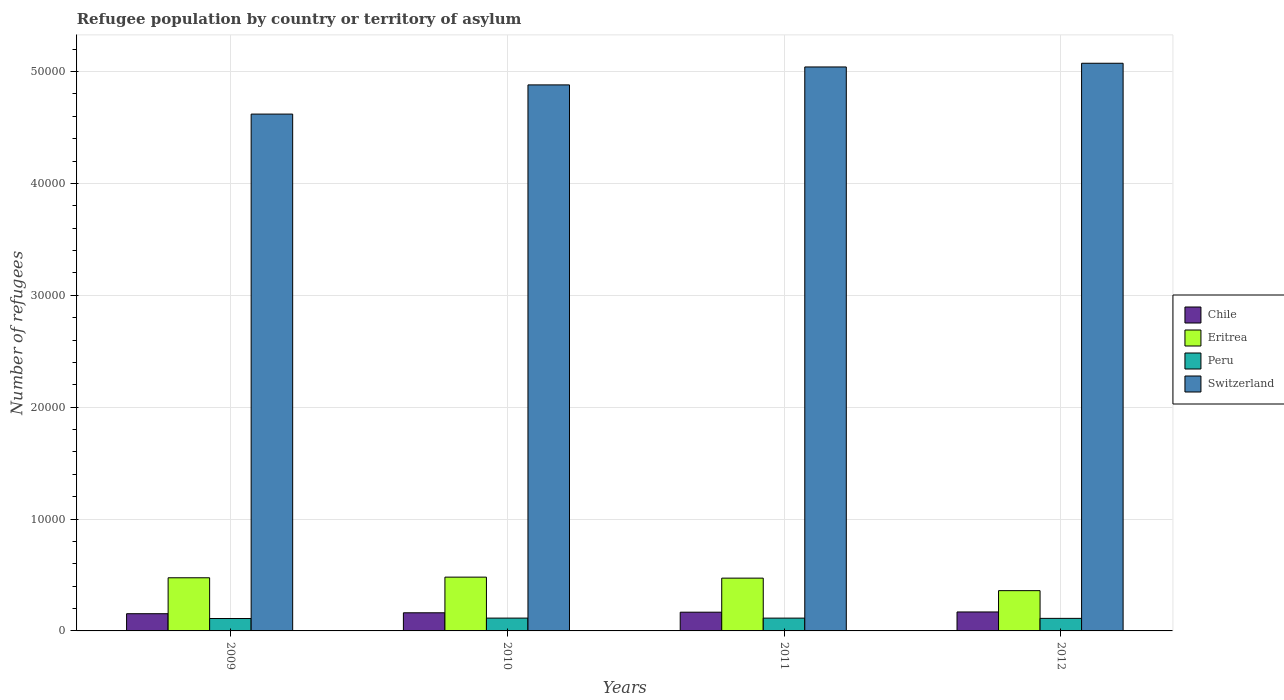How many different coloured bars are there?
Keep it short and to the point. 4. Are the number of bars per tick equal to the number of legend labels?
Make the answer very short. Yes. What is the label of the 3rd group of bars from the left?
Your answer should be compact. 2011. What is the number of refugees in Eritrea in 2012?
Keep it short and to the point. 3600. Across all years, what is the maximum number of refugees in Peru?
Make the answer very short. 1146. Across all years, what is the minimum number of refugees in Chile?
Your answer should be very brief. 1539. In which year was the number of refugees in Peru maximum?
Keep it short and to the point. 2010. What is the total number of refugees in Switzerland in the graph?
Make the answer very short. 1.96e+05. What is the difference between the number of refugees in Chile in 2009 and that in 2012?
Make the answer very short. -156. What is the difference between the number of refugees in Eritrea in 2011 and the number of refugees in Peru in 2009?
Keep it short and to the point. 3611. What is the average number of refugees in Switzerland per year?
Your answer should be compact. 4.90e+04. In the year 2012, what is the difference between the number of refugees in Switzerland and number of refugees in Peru?
Your answer should be compact. 4.96e+04. In how many years, is the number of refugees in Peru greater than 40000?
Your response must be concise. 0. What is the ratio of the number of refugees in Peru in 2009 to that in 2012?
Keep it short and to the point. 0.99. Is the number of refugees in Chile in 2009 less than that in 2011?
Give a very brief answer. Yes. What is the difference between the highest and the lowest number of refugees in Switzerland?
Ensure brevity in your answer.  4544. Is the sum of the number of refugees in Chile in 2010 and 2012 greater than the maximum number of refugees in Peru across all years?
Your answer should be compact. Yes. How many bars are there?
Keep it short and to the point. 16. What is the difference between two consecutive major ticks on the Y-axis?
Give a very brief answer. 10000. Does the graph contain any zero values?
Offer a terse response. No. Where does the legend appear in the graph?
Provide a succinct answer. Center right. How many legend labels are there?
Offer a very short reply. 4. How are the legend labels stacked?
Make the answer very short. Vertical. What is the title of the graph?
Your answer should be compact. Refugee population by country or territory of asylum. What is the label or title of the X-axis?
Your response must be concise. Years. What is the label or title of the Y-axis?
Offer a very short reply. Number of refugees. What is the Number of refugees in Chile in 2009?
Provide a short and direct response. 1539. What is the Number of refugees of Eritrea in 2009?
Your answer should be compact. 4751. What is the Number of refugees of Peru in 2009?
Keep it short and to the point. 1108. What is the Number of refugees in Switzerland in 2009?
Offer a very short reply. 4.62e+04. What is the Number of refugees of Chile in 2010?
Provide a succinct answer. 1621. What is the Number of refugees in Eritrea in 2010?
Your response must be concise. 4809. What is the Number of refugees of Peru in 2010?
Your response must be concise. 1146. What is the Number of refugees of Switzerland in 2010?
Offer a terse response. 4.88e+04. What is the Number of refugees of Chile in 2011?
Give a very brief answer. 1674. What is the Number of refugees of Eritrea in 2011?
Offer a very short reply. 4719. What is the Number of refugees in Peru in 2011?
Make the answer very short. 1144. What is the Number of refugees of Switzerland in 2011?
Your answer should be very brief. 5.04e+04. What is the Number of refugees in Chile in 2012?
Your answer should be compact. 1695. What is the Number of refugees in Eritrea in 2012?
Your answer should be compact. 3600. What is the Number of refugees in Peru in 2012?
Provide a short and direct response. 1122. What is the Number of refugees in Switzerland in 2012?
Make the answer very short. 5.07e+04. Across all years, what is the maximum Number of refugees of Chile?
Make the answer very short. 1695. Across all years, what is the maximum Number of refugees in Eritrea?
Ensure brevity in your answer.  4809. Across all years, what is the maximum Number of refugees of Peru?
Offer a very short reply. 1146. Across all years, what is the maximum Number of refugees in Switzerland?
Your answer should be compact. 5.07e+04. Across all years, what is the minimum Number of refugees of Chile?
Provide a succinct answer. 1539. Across all years, what is the minimum Number of refugees in Eritrea?
Your response must be concise. 3600. Across all years, what is the minimum Number of refugees of Peru?
Provide a short and direct response. 1108. Across all years, what is the minimum Number of refugees in Switzerland?
Offer a terse response. 4.62e+04. What is the total Number of refugees in Chile in the graph?
Ensure brevity in your answer.  6529. What is the total Number of refugees of Eritrea in the graph?
Make the answer very short. 1.79e+04. What is the total Number of refugees of Peru in the graph?
Offer a very short reply. 4520. What is the total Number of refugees of Switzerland in the graph?
Give a very brief answer. 1.96e+05. What is the difference between the Number of refugees in Chile in 2009 and that in 2010?
Offer a terse response. -82. What is the difference between the Number of refugees of Eritrea in 2009 and that in 2010?
Provide a succinct answer. -58. What is the difference between the Number of refugees of Peru in 2009 and that in 2010?
Ensure brevity in your answer.  -38. What is the difference between the Number of refugees of Switzerland in 2009 and that in 2010?
Provide a succinct answer. -2610. What is the difference between the Number of refugees in Chile in 2009 and that in 2011?
Your response must be concise. -135. What is the difference between the Number of refugees of Eritrea in 2009 and that in 2011?
Your response must be concise. 32. What is the difference between the Number of refugees in Peru in 2009 and that in 2011?
Offer a terse response. -36. What is the difference between the Number of refugees in Switzerland in 2009 and that in 2011?
Give a very brief answer. -4213. What is the difference between the Number of refugees in Chile in 2009 and that in 2012?
Offer a terse response. -156. What is the difference between the Number of refugees of Eritrea in 2009 and that in 2012?
Your answer should be compact. 1151. What is the difference between the Number of refugees in Peru in 2009 and that in 2012?
Your response must be concise. -14. What is the difference between the Number of refugees in Switzerland in 2009 and that in 2012?
Keep it short and to the point. -4544. What is the difference between the Number of refugees of Chile in 2010 and that in 2011?
Give a very brief answer. -53. What is the difference between the Number of refugees in Peru in 2010 and that in 2011?
Provide a short and direct response. 2. What is the difference between the Number of refugees in Switzerland in 2010 and that in 2011?
Provide a short and direct response. -1603. What is the difference between the Number of refugees in Chile in 2010 and that in 2012?
Keep it short and to the point. -74. What is the difference between the Number of refugees of Eritrea in 2010 and that in 2012?
Give a very brief answer. 1209. What is the difference between the Number of refugees of Peru in 2010 and that in 2012?
Your response must be concise. 24. What is the difference between the Number of refugees of Switzerland in 2010 and that in 2012?
Your response must be concise. -1934. What is the difference between the Number of refugees of Chile in 2011 and that in 2012?
Your answer should be very brief. -21. What is the difference between the Number of refugees of Eritrea in 2011 and that in 2012?
Give a very brief answer. 1119. What is the difference between the Number of refugees in Switzerland in 2011 and that in 2012?
Your answer should be compact. -331. What is the difference between the Number of refugees of Chile in 2009 and the Number of refugees of Eritrea in 2010?
Offer a terse response. -3270. What is the difference between the Number of refugees of Chile in 2009 and the Number of refugees of Peru in 2010?
Provide a short and direct response. 393. What is the difference between the Number of refugees in Chile in 2009 and the Number of refugees in Switzerland in 2010?
Give a very brief answer. -4.73e+04. What is the difference between the Number of refugees of Eritrea in 2009 and the Number of refugees of Peru in 2010?
Offer a terse response. 3605. What is the difference between the Number of refugees in Eritrea in 2009 and the Number of refugees in Switzerland in 2010?
Make the answer very short. -4.41e+04. What is the difference between the Number of refugees of Peru in 2009 and the Number of refugees of Switzerland in 2010?
Keep it short and to the point. -4.77e+04. What is the difference between the Number of refugees in Chile in 2009 and the Number of refugees in Eritrea in 2011?
Make the answer very short. -3180. What is the difference between the Number of refugees in Chile in 2009 and the Number of refugees in Peru in 2011?
Offer a very short reply. 395. What is the difference between the Number of refugees in Chile in 2009 and the Number of refugees in Switzerland in 2011?
Give a very brief answer. -4.89e+04. What is the difference between the Number of refugees in Eritrea in 2009 and the Number of refugees in Peru in 2011?
Provide a short and direct response. 3607. What is the difference between the Number of refugees in Eritrea in 2009 and the Number of refugees in Switzerland in 2011?
Offer a terse response. -4.57e+04. What is the difference between the Number of refugees of Peru in 2009 and the Number of refugees of Switzerland in 2011?
Offer a terse response. -4.93e+04. What is the difference between the Number of refugees in Chile in 2009 and the Number of refugees in Eritrea in 2012?
Your response must be concise. -2061. What is the difference between the Number of refugees in Chile in 2009 and the Number of refugees in Peru in 2012?
Provide a short and direct response. 417. What is the difference between the Number of refugees of Chile in 2009 and the Number of refugees of Switzerland in 2012?
Offer a terse response. -4.92e+04. What is the difference between the Number of refugees of Eritrea in 2009 and the Number of refugees of Peru in 2012?
Your answer should be very brief. 3629. What is the difference between the Number of refugees of Eritrea in 2009 and the Number of refugees of Switzerland in 2012?
Make the answer very short. -4.60e+04. What is the difference between the Number of refugees in Peru in 2009 and the Number of refugees in Switzerland in 2012?
Offer a terse response. -4.96e+04. What is the difference between the Number of refugees of Chile in 2010 and the Number of refugees of Eritrea in 2011?
Offer a very short reply. -3098. What is the difference between the Number of refugees of Chile in 2010 and the Number of refugees of Peru in 2011?
Offer a very short reply. 477. What is the difference between the Number of refugees of Chile in 2010 and the Number of refugees of Switzerland in 2011?
Keep it short and to the point. -4.88e+04. What is the difference between the Number of refugees of Eritrea in 2010 and the Number of refugees of Peru in 2011?
Offer a very short reply. 3665. What is the difference between the Number of refugees of Eritrea in 2010 and the Number of refugees of Switzerland in 2011?
Provide a short and direct response. -4.56e+04. What is the difference between the Number of refugees in Peru in 2010 and the Number of refugees in Switzerland in 2011?
Offer a very short reply. -4.93e+04. What is the difference between the Number of refugees of Chile in 2010 and the Number of refugees of Eritrea in 2012?
Ensure brevity in your answer.  -1979. What is the difference between the Number of refugees in Chile in 2010 and the Number of refugees in Peru in 2012?
Make the answer very short. 499. What is the difference between the Number of refugees of Chile in 2010 and the Number of refugees of Switzerland in 2012?
Ensure brevity in your answer.  -4.91e+04. What is the difference between the Number of refugees of Eritrea in 2010 and the Number of refugees of Peru in 2012?
Your answer should be very brief. 3687. What is the difference between the Number of refugees in Eritrea in 2010 and the Number of refugees in Switzerland in 2012?
Give a very brief answer. -4.59e+04. What is the difference between the Number of refugees of Peru in 2010 and the Number of refugees of Switzerland in 2012?
Your answer should be very brief. -4.96e+04. What is the difference between the Number of refugees in Chile in 2011 and the Number of refugees in Eritrea in 2012?
Your answer should be very brief. -1926. What is the difference between the Number of refugees in Chile in 2011 and the Number of refugees in Peru in 2012?
Give a very brief answer. 552. What is the difference between the Number of refugees of Chile in 2011 and the Number of refugees of Switzerland in 2012?
Your answer should be compact. -4.91e+04. What is the difference between the Number of refugees of Eritrea in 2011 and the Number of refugees of Peru in 2012?
Your answer should be compact. 3597. What is the difference between the Number of refugees of Eritrea in 2011 and the Number of refugees of Switzerland in 2012?
Give a very brief answer. -4.60e+04. What is the difference between the Number of refugees in Peru in 2011 and the Number of refugees in Switzerland in 2012?
Your answer should be compact. -4.96e+04. What is the average Number of refugees in Chile per year?
Provide a short and direct response. 1632.25. What is the average Number of refugees in Eritrea per year?
Your response must be concise. 4469.75. What is the average Number of refugees of Peru per year?
Your answer should be compact. 1130. What is the average Number of refugees in Switzerland per year?
Your answer should be very brief. 4.90e+04. In the year 2009, what is the difference between the Number of refugees of Chile and Number of refugees of Eritrea?
Your answer should be very brief. -3212. In the year 2009, what is the difference between the Number of refugees in Chile and Number of refugees in Peru?
Provide a short and direct response. 431. In the year 2009, what is the difference between the Number of refugees in Chile and Number of refugees in Switzerland?
Make the answer very short. -4.47e+04. In the year 2009, what is the difference between the Number of refugees in Eritrea and Number of refugees in Peru?
Make the answer very short. 3643. In the year 2009, what is the difference between the Number of refugees of Eritrea and Number of refugees of Switzerland?
Your response must be concise. -4.15e+04. In the year 2009, what is the difference between the Number of refugees of Peru and Number of refugees of Switzerland?
Your answer should be compact. -4.51e+04. In the year 2010, what is the difference between the Number of refugees in Chile and Number of refugees in Eritrea?
Keep it short and to the point. -3188. In the year 2010, what is the difference between the Number of refugees of Chile and Number of refugees of Peru?
Offer a terse response. 475. In the year 2010, what is the difference between the Number of refugees of Chile and Number of refugees of Switzerland?
Offer a terse response. -4.72e+04. In the year 2010, what is the difference between the Number of refugees in Eritrea and Number of refugees in Peru?
Provide a short and direct response. 3663. In the year 2010, what is the difference between the Number of refugees of Eritrea and Number of refugees of Switzerland?
Provide a short and direct response. -4.40e+04. In the year 2010, what is the difference between the Number of refugees of Peru and Number of refugees of Switzerland?
Your answer should be compact. -4.77e+04. In the year 2011, what is the difference between the Number of refugees of Chile and Number of refugees of Eritrea?
Offer a terse response. -3045. In the year 2011, what is the difference between the Number of refugees of Chile and Number of refugees of Peru?
Ensure brevity in your answer.  530. In the year 2011, what is the difference between the Number of refugees in Chile and Number of refugees in Switzerland?
Provide a short and direct response. -4.87e+04. In the year 2011, what is the difference between the Number of refugees in Eritrea and Number of refugees in Peru?
Offer a terse response. 3575. In the year 2011, what is the difference between the Number of refugees in Eritrea and Number of refugees in Switzerland?
Your answer should be compact. -4.57e+04. In the year 2011, what is the difference between the Number of refugees of Peru and Number of refugees of Switzerland?
Your response must be concise. -4.93e+04. In the year 2012, what is the difference between the Number of refugees in Chile and Number of refugees in Eritrea?
Offer a very short reply. -1905. In the year 2012, what is the difference between the Number of refugees of Chile and Number of refugees of Peru?
Offer a terse response. 573. In the year 2012, what is the difference between the Number of refugees in Chile and Number of refugees in Switzerland?
Your response must be concise. -4.91e+04. In the year 2012, what is the difference between the Number of refugees of Eritrea and Number of refugees of Peru?
Ensure brevity in your answer.  2478. In the year 2012, what is the difference between the Number of refugees in Eritrea and Number of refugees in Switzerland?
Ensure brevity in your answer.  -4.71e+04. In the year 2012, what is the difference between the Number of refugees of Peru and Number of refugees of Switzerland?
Keep it short and to the point. -4.96e+04. What is the ratio of the Number of refugees in Chile in 2009 to that in 2010?
Provide a succinct answer. 0.95. What is the ratio of the Number of refugees in Eritrea in 2009 to that in 2010?
Make the answer very short. 0.99. What is the ratio of the Number of refugees in Peru in 2009 to that in 2010?
Your answer should be compact. 0.97. What is the ratio of the Number of refugees of Switzerland in 2009 to that in 2010?
Keep it short and to the point. 0.95. What is the ratio of the Number of refugees of Chile in 2009 to that in 2011?
Make the answer very short. 0.92. What is the ratio of the Number of refugees in Eritrea in 2009 to that in 2011?
Offer a very short reply. 1.01. What is the ratio of the Number of refugees of Peru in 2009 to that in 2011?
Ensure brevity in your answer.  0.97. What is the ratio of the Number of refugees in Switzerland in 2009 to that in 2011?
Offer a very short reply. 0.92. What is the ratio of the Number of refugees in Chile in 2009 to that in 2012?
Your response must be concise. 0.91. What is the ratio of the Number of refugees in Eritrea in 2009 to that in 2012?
Keep it short and to the point. 1.32. What is the ratio of the Number of refugees in Peru in 2009 to that in 2012?
Keep it short and to the point. 0.99. What is the ratio of the Number of refugees in Switzerland in 2009 to that in 2012?
Ensure brevity in your answer.  0.91. What is the ratio of the Number of refugees in Chile in 2010 to that in 2011?
Your answer should be compact. 0.97. What is the ratio of the Number of refugees of Eritrea in 2010 to that in 2011?
Provide a short and direct response. 1.02. What is the ratio of the Number of refugees of Peru in 2010 to that in 2011?
Provide a short and direct response. 1. What is the ratio of the Number of refugees in Switzerland in 2010 to that in 2011?
Keep it short and to the point. 0.97. What is the ratio of the Number of refugees of Chile in 2010 to that in 2012?
Your answer should be compact. 0.96. What is the ratio of the Number of refugees of Eritrea in 2010 to that in 2012?
Give a very brief answer. 1.34. What is the ratio of the Number of refugees in Peru in 2010 to that in 2012?
Offer a very short reply. 1.02. What is the ratio of the Number of refugees in Switzerland in 2010 to that in 2012?
Provide a short and direct response. 0.96. What is the ratio of the Number of refugees of Chile in 2011 to that in 2012?
Make the answer very short. 0.99. What is the ratio of the Number of refugees in Eritrea in 2011 to that in 2012?
Your response must be concise. 1.31. What is the ratio of the Number of refugees of Peru in 2011 to that in 2012?
Ensure brevity in your answer.  1.02. What is the ratio of the Number of refugees of Switzerland in 2011 to that in 2012?
Your answer should be very brief. 0.99. What is the difference between the highest and the second highest Number of refugees of Chile?
Your response must be concise. 21. What is the difference between the highest and the second highest Number of refugees in Eritrea?
Your answer should be very brief. 58. What is the difference between the highest and the second highest Number of refugees in Switzerland?
Offer a terse response. 331. What is the difference between the highest and the lowest Number of refugees in Chile?
Provide a succinct answer. 156. What is the difference between the highest and the lowest Number of refugees of Eritrea?
Provide a short and direct response. 1209. What is the difference between the highest and the lowest Number of refugees of Switzerland?
Offer a very short reply. 4544. 